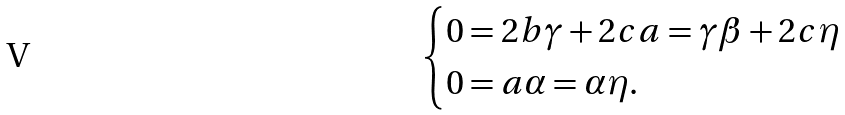<formula> <loc_0><loc_0><loc_500><loc_500>\begin{cases} 0 = 2 b \gamma + 2 c a = \gamma \beta + 2 c \eta \\ 0 = a \alpha = \alpha \eta . \end{cases}</formula> 